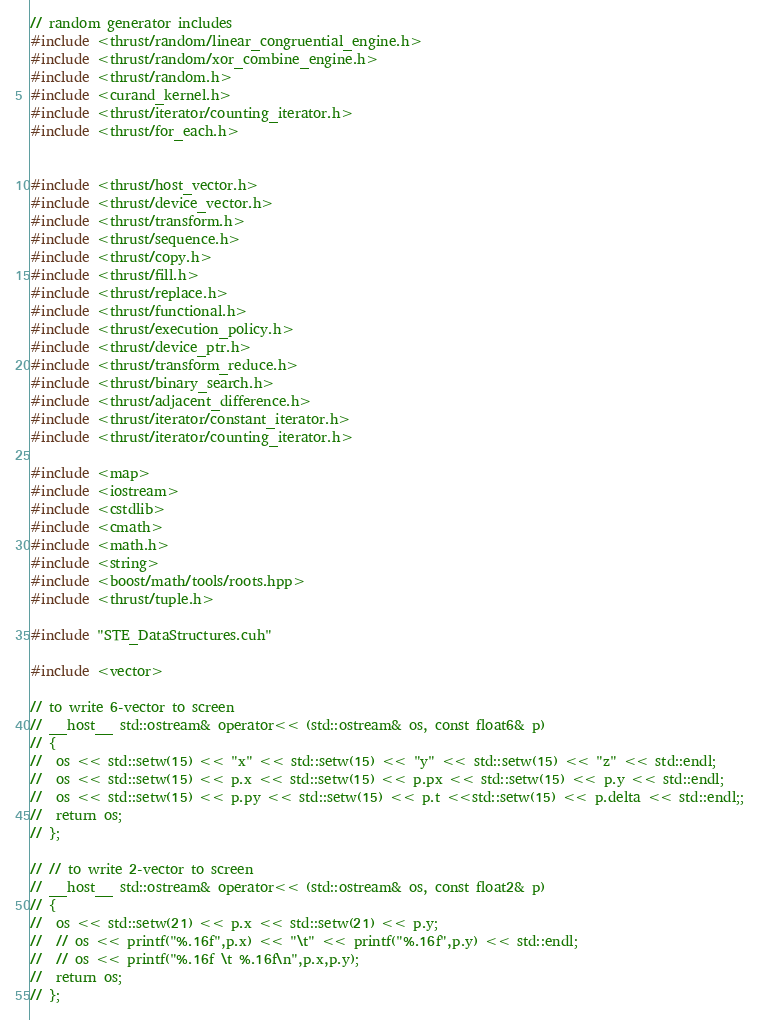<code> <loc_0><loc_0><loc_500><loc_500><_Cuda_>// random generator includes
#include <thrust/random/linear_congruential_engine.h>
#include <thrust/random/xor_combine_engine.h>
#include <thrust/random.h>
#include <curand_kernel.h>
#include <thrust/iterator/counting_iterator.h>
#include <thrust/for_each.h>


#include <thrust/host_vector.h>
#include <thrust/device_vector.h>
#include <thrust/transform.h>
#include <thrust/sequence.h>
#include <thrust/copy.h>
#include <thrust/fill.h>
#include <thrust/replace.h>
#include <thrust/functional.h>
#include <thrust/execution_policy.h>
#include <thrust/device_ptr.h>
#include <thrust/transform_reduce.h>
#include <thrust/binary_search.h>
#include <thrust/adjacent_difference.h>
#include <thrust/iterator/constant_iterator.h>
#include <thrust/iterator/counting_iterator.h>

#include <map>
#include <iostream>
#include <cstdlib>
#include <cmath>
#include <math.h>
#include <string>
#include <boost/math/tools/roots.hpp>
#include <thrust/tuple.h>

#include "STE_DataStructures.cuh"

#include <vector>

// to write 6-vector to screen
// __host__ std::ostream& operator<< (std::ostream& os, const float6& p)
// {
// 	os << std::setw(15) << "x" << std::setw(15) << "y" << std::setw(15) << "z" << std::endl;
// 	os << std::setw(15) << p.x << std::setw(15) << p.px << std::setw(15) << p.y << std::endl;
// 	os << std::setw(15) << p.py << std::setw(15) << p.t <<std::setw(15) << p.delta << std::endl;;
// 	return os;
// };

// // to write 2-vector to screen
// __host__ std::ostream& operator<< (std::ostream& os, const float2& p)
// {
// 	os << std::setw(21) << p.x << std::setw(21) << p.y;
// 	// os << printf("%.16f",p.x) << "\t" << printf("%.16f",p.y) << std::endl;
// 	// os << printf("%.16f \t %.16f\n",p.x,p.y);
// 	return os;
// };
</code> 